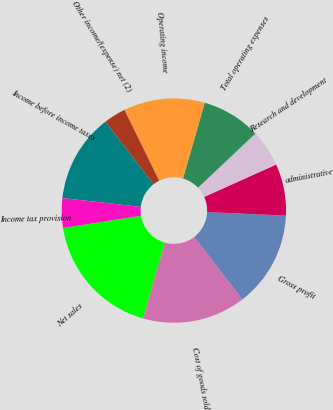<chart> <loc_0><loc_0><loc_500><loc_500><pie_chart><fcel>Net sales<fcel>Cost of goods sold<fcel>Gross profit<fcel>administrative<fcel>Research and development<fcel>Total operating expenses<fcel>Operating income<fcel>Other income/(expense) net (2)<fcel>Income before income taxes<fcel>Income tax provision<nl><fcel>18.09%<fcel>14.89%<fcel>13.83%<fcel>7.45%<fcel>5.32%<fcel>8.51%<fcel>11.7%<fcel>3.19%<fcel>12.77%<fcel>4.26%<nl></chart> 